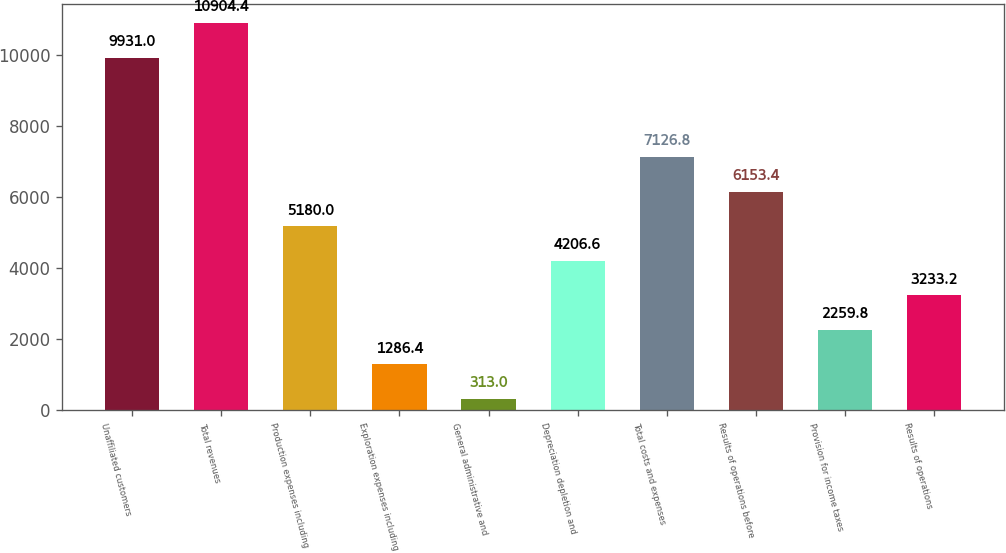<chart> <loc_0><loc_0><loc_500><loc_500><bar_chart><fcel>Unaffiliated customers<fcel>Total revenues<fcel>Production expenses including<fcel>Exploration expenses including<fcel>General administrative and<fcel>Depreciation depletion and<fcel>Total costs and expenses<fcel>Results of operations before<fcel>Provision for income taxes<fcel>Results of operations<nl><fcel>9931<fcel>10904.4<fcel>5180<fcel>1286.4<fcel>313<fcel>4206.6<fcel>7126.8<fcel>6153.4<fcel>2259.8<fcel>3233.2<nl></chart> 